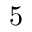Convert formula to latex. <formula><loc_0><loc_0><loc_500><loc_500>5</formula> 